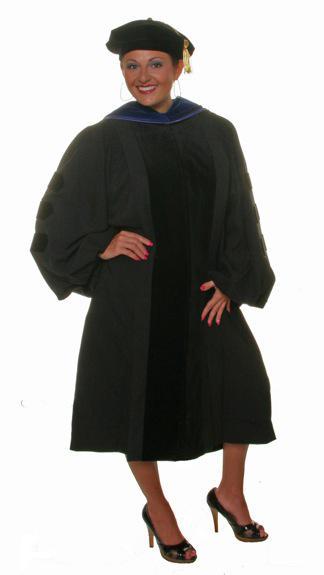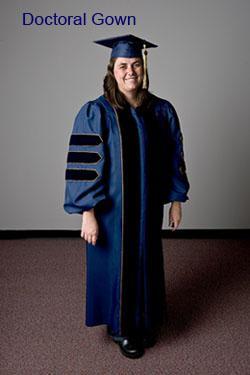The first image is the image on the left, the second image is the image on the right. For the images displayed, is the sentence "There is a woman in the image on the right." factually correct? Answer yes or no. Yes. 